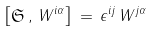Convert formula to latex. <formula><loc_0><loc_0><loc_500><loc_500>\left [ \mathfrak { S } \, , \, W ^ { i \alpha } \right ] \, = \, \epsilon ^ { i j } \, W ^ { j \alpha }</formula> 